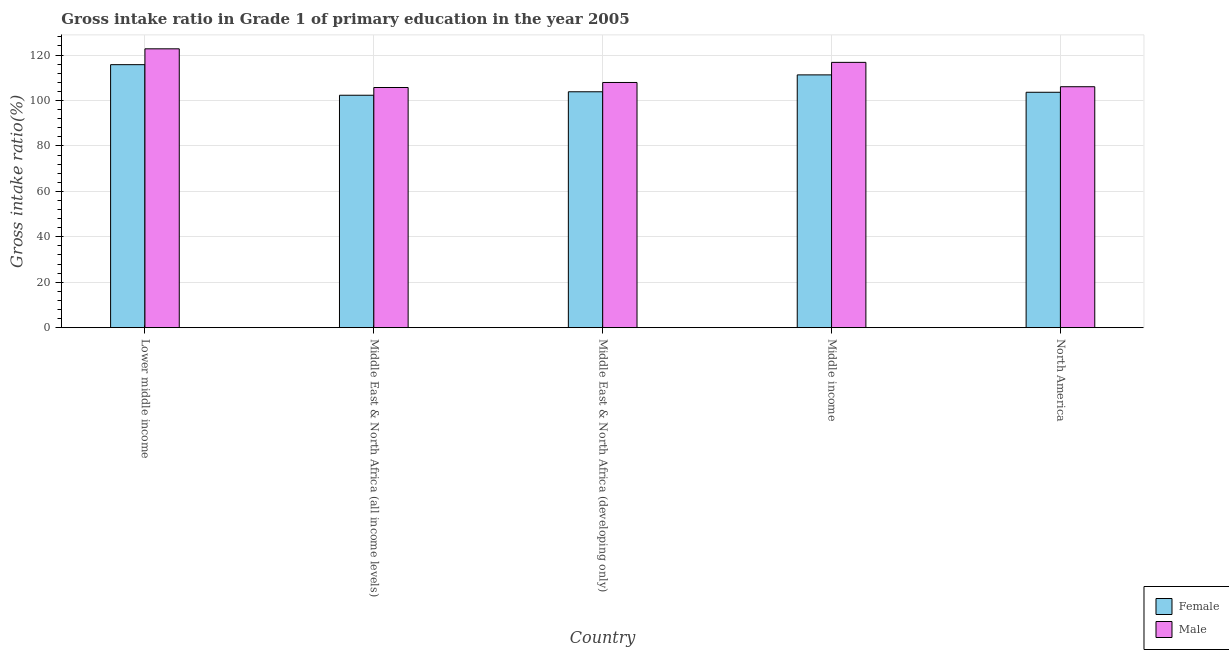How many different coloured bars are there?
Your response must be concise. 2. Are the number of bars per tick equal to the number of legend labels?
Provide a succinct answer. Yes. How many bars are there on the 1st tick from the left?
Provide a succinct answer. 2. What is the label of the 1st group of bars from the left?
Your answer should be compact. Lower middle income. In how many cases, is the number of bars for a given country not equal to the number of legend labels?
Offer a very short reply. 0. What is the gross intake ratio(female) in Middle East & North Africa (all income levels)?
Your answer should be very brief. 102.32. Across all countries, what is the maximum gross intake ratio(male)?
Offer a terse response. 122.75. Across all countries, what is the minimum gross intake ratio(male)?
Provide a succinct answer. 105.72. In which country was the gross intake ratio(female) maximum?
Your answer should be very brief. Lower middle income. In which country was the gross intake ratio(male) minimum?
Keep it short and to the point. Middle East & North Africa (all income levels). What is the total gross intake ratio(female) in the graph?
Offer a terse response. 536.83. What is the difference between the gross intake ratio(female) in Middle East & North Africa (all income levels) and that in Middle East & North Africa (developing only)?
Make the answer very short. -1.52. What is the difference between the gross intake ratio(female) in Lower middle income and the gross intake ratio(male) in Middle East & North Africa (all income levels)?
Ensure brevity in your answer.  10.06. What is the average gross intake ratio(male) per country?
Your answer should be very brief. 111.85. What is the difference between the gross intake ratio(female) and gross intake ratio(male) in Middle East & North Africa (all income levels)?
Your answer should be very brief. -3.4. What is the ratio of the gross intake ratio(female) in Middle East & North Africa (all income levels) to that in Middle income?
Offer a terse response. 0.92. Is the gross intake ratio(female) in Lower middle income less than that in Middle income?
Your response must be concise. No. What is the difference between the highest and the second highest gross intake ratio(female)?
Provide a short and direct response. 4.5. What is the difference between the highest and the lowest gross intake ratio(male)?
Ensure brevity in your answer.  17.03. Is the sum of the gross intake ratio(male) in Lower middle income and North America greater than the maximum gross intake ratio(female) across all countries?
Offer a very short reply. Yes. What does the 2nd bar from the left in North America represents?
Provide a short and direct response. Male. What does the 1st bar from the right in Middle income represents?
Your response must be concise. Male. Are the values on the major ticks of Y-axis written in scientific E-notation?
Your response must be concise. No. Does the graph contain any zero values?
Offer a very short reply. No. How are the legend labels stacked?
Keep it short and to the point. Vertical. What is the title of the graph?
Your response must be concise. Gross intake ratio in Grade 1 of primary education in the year 2005. What is the label or title of the Y-axis?
Give a very brief answer. Gross intake ratio(%). What is the Gross intake ratio(%) in Female in Lower middle income?
Give a very brief answer. 115.78. What is the Gross intake ratio(%) in Male in Lower middle income?
Your answer should be very brief. 122.75. What is the Gross intake ratio(%) of Female in Middle East & North Africa (all income levels)?
Offer a very short reply. 102.32. What is the Gross intake ratio(%) of Male in Middle East & North Africa (all income levels)?
Your response must be concise. 105.72. What is the Gross intake ratio(%) of Female in Middle East & North Africa (developing only)?
Your answer should be compact. 103.84. What is the Gross intake ratio(%) in Male in Middle East & North Africa (developing only)?
Keep it short and to the point. 107.93. What is the Gross intake ratio(%) in Female in Middle income?
Offer a terse response. 111.27. What is the Gross intake ratio(%) of Male in Middle income?
Provide a short and direct response. 116.79. What is the Gross intake ratio(%) of Female in North America?
Offer a terse response. 103.62. What is the Gross intake ratio(%) in Male in North America?
Offer a very short reply. 106.07. Across all countries, what is the maximum Gross intake ratio(%) in Female?
Offer a very short reply. 115.78. Across all countries, what is the maximum Gross intake ratio(%) of Male?
Give a very brief answer. 122.75. Across all countries, what is the minimum Gross intake ratio(%) in Female?
Provide a succinct answer. 102.32. Across all countries, what is the minimum Gross intake ratio(%) in Male?
Ensure brevity in your answer.  105.72. What is the total Gross intake ratio(%) of Female in the graph?
Your answer should be compact. 536.83. What is the total Gross intake ratio(%) of Male in the graph?
Offer a very short reply. 559.25. What is the difference between the Gross intake ratio(%) in Female in Lower middle income and that in Middle East & North Africa (all income levels)?
Provide a short and direct response. 13.46. What is the difference between the Gross intake ratio(%) in Male in Lower middle income and that in Middle East & North Africa (all income levels)?
Provide a short and direct response. 17.03. What is the difference between the Gross intake ratio(%) in Female in Lower middle income and that in Middle East & North Africa (developing only)?
Provide a short and direct response. 11.94. What is the difference between the Gross intake ratio(%) in Male in Lower middle income and that in Middle East & North Africa (developing only)?
Give a very brief answer. 14.82. What is the difference between the Gross intake ratio(%) in Female in Lower middle income and that in Middle income?
Your answer should be compact. 4.5. What is the difference between the Gross intake ratio(%) in Male in Lower middle income and that in Middle income?
Make the answer very short. 5.96. What is the difference between the Gross intake ratio(%) in Female in Lower middle income and that in North America?
Your answer should be compact. 12.15. What is the difference between the Gross intake ratio(%) in Male in Lower middle income and that in North America?
Give a very brief answer. 16.68. What is the difference between the Gross intake ratio(%) of Female in Middle East & North Africa (all income levels) and that in Middle East & North Africa (developing only)?
Offer a terse response. -1.52. What is the difference between the Gross intake ratio(%) of Male in Middle East & North Africa (all income levels) and that in Middle East & North Africa (developing only)?
Your response must be concise. -2.21. What is the difference between the Gross intake ratio(%) in Female in Middle East & North Africa (all income levels) and that in Middle income?
Ensure brevity in your answer.  -8.96. What is the difference between the Gross intake ratio(%) of Male in Middle East & North Africa (all income levels) and that in Middle income?
Keep it short and to the point. -11.07. What is the difference between the Gross intake ratio(%) in Female in Middle East & North Africa (all income levels) and that in North America?
Give a very brief answer. -1.31. What is the difference between the Gross intake ratio(%) of Male in Middle East & North Africa (all income levels) and that in North America?
Provide a succinct answer. -0.35. What is the difference between the Gross intake ratio(%) in Female in Middle East & North Africa (developing only) and that in Middle income?
Offer a very short reply. -7.44. What is the difference between the Gross intake ratio(%) of Male in Middle East & North Africa (developing only) and that in Middle income?
Your answer should be very brief. -8.86. What is the difference between the Gross intake ratio(%) in Female in Middle East & North Africa (developing only) and that in North America?
Provide a short and direct response. 0.22. What is the difference between the Gross intake ratio(%) of Male in Middle East & North Africa (developing only) and that in North America?
Offer a terse response. 1.86. What is the difference between the Gross intake ratio(%) of Female in Middle income and that in North America?
Your answer should be compact. 7.65. What is the difference between the Gross intake ratio(%) in Male in Middle income and that in North America?
Offer a very short reply. 10.72. What is the difference between the Gross intake ratio(%) in Female in Lower middle income and the Gross intake ratio(%) in Male in Middle East & North Africa (all income levels)?
Your answer should be very brief. 10.06. What is the difference between the Gross intake ratio(%) of Female in Lower middle income and the Gross intake ratio(%) of Male in Middle East & North Africa (developing only)?
Your answer should be very brief. 7.85. What is the difference between the Gross intake ratio(%) of Female in Lower middle income and the Gross intake ratio(%) of Male in Middle income?
Ensure brevity in your answer.  -1.01. What is the difference between the Gross intake ratio(%) in Female in Lower middle income and the Gross intake ratio(%) in Male in North America?
Your answer should be compact. 9.71. What is the difference between the Gross intake ratio(%) of Female in Middle East & North Africa (all income levels) and the Gross intake ratio(%) of Male in Middle East & North Africa (developing only)?
Offer a very short reply. -5.61. What is the difference between the Gross intake ratio(%) in Female in Middle East & North Africa (all income levels) and the Gross intake ratio(%) in Male in Middle income?
Your response must be concise. -14.47. What is the difference between the Gross intake ratio(%) of Female in Middle East & North Africa (all income levels) and the Gross intake ratio(%) of Male in North America?
Provide a succinct answer. -3.75. What is the difference between the Gross intake ratio(%) of Female in Middle East & North Africa (developing only) and the Gross intake ratio(%) of Male in Middle income?
Offer a very short reply. -12.95. What is the difference between the Gross intake ratio(%) of Female in Middle East & North Africa (developing only) and the Gross intake ratio(%) of Male in North America?
Keep it short and to the point. -2.23. What is the difference between the Gross intake ratio(%) of Female in Middle income and the Gross intake ratio(%) of Male in North America?
Make the answer very short. 5.21. What is the average Gross intake ratio(%) in Female per country?
Your answer should be very brief. 107.37. What is the average Gross intake ratio(%) of Male per country?
Keep it short and to the point. 111.85. What is the difference between the Gross intake ratio(%) in Female and Gross intake ratio(%) in Male in Lower middle income?
Provide a succinct answer. -6.97. What is the difference between the Gross intake ratio(%) of Female and Gross intake ratio(%) of Male in Middle East & North Africa (all income levels)?
Your answer should be very brief. -3.4. What is the difference between the Gross intake ratio(%) of Female and Gross intake ratio(%) of Male in Middle East & North Africa (developing only)?
Ensure brevity in your answer.  -4.09. What is the difference between the Gross intake ratio(%) in Female and Gross intake ratio(%) in Male in Middle income?
Provide a short and direct response. -5.51. What is the difference between the Gross intake ratio(%) in Female and Gross intake ratio(%) in Male in North America?
Your response must be concise. -2.44. What is the ratio of the Gross intake ratio(%) in Female in Lower middle income to that in Middle East & North Africa (all income levels)?
Give a very brief answer. 1.13. What is the ratio of the Gross intake ratio(%) in Male in Lower middle income to that in Middle East & North Africa (all income levels)?
Ensure brevity in your answer.  1.16. What is the ratio of the Gross intake ratio(%) of Female in Lower middle income to that in Middle East & North Africa (developing only)?
Your answer should be very brief. 1.11. What is the ratio of the Gross intake ratio(%) in Male in Lower middle income to that in Middle East & North Africa (developing only)?
Provide a succinct answer. 1.14. What is the ratio of the Gross intake ratio(%) of Female in Lower middle income to that in Middle income?
Offer a very short reply. 1.04. What is the ratio of the Gross intake ratio(%) in Male in Lower middle income to that in Middle income?
Make the answer very short. 1.05. What is the ratio of the Gross intake ratio(%) in Female in Lower middle income to that in North America?
Your response must be concise. 1.12. What is the ratio of the Gross intake ratio(%) of Male in Lower middle income to that in North America?
Provide a short and direct response. 1.16. What is the ratio of the Gross intake ratio(%) of Female in Middle East & North Africa (all income levels) to that in Middle East & North Africa (developing only)?
Offer a terse response. 0.99. What is the ratio of the Gross intake ratio(%) in Male in Middle East & North Africa (all income levels) to that in Middle East & North Africa (developing only)?
Make the answer very short. 0.98. What is the ratio of the Gross intake ratio(%) of Female in Middle East & North Africa (all income levels) to that in Middle income?
Keep it short and to the point. 0.92. What is the ratio of the Gross intake ratio(%) of Male in Middle East & North Africa (all income levels) to that in Middle income?
Provide a succinct answer. 0.91. What is the ratio of the Gross intake ratio(%) of Female in Middle East & North Africa (all income levels) to that in North America?
Your answer should be compact. 0.99. What is the ratio of the Gross intake ratio(%) in Female in Middle East & North Africa (developing only) to that in Middle income?
Offer a terse response. 0.93. What is the ratio of the Gross intake ratio(%) in Male in Middle East & North Africa (developing only) to that in Middle income?
Offer a terse response. 0.92. What is the ratio of the Gross intake ratio(%) in Male in Middle East & North Africa (developing only) to that in North America?
Offer a very short reply. 1.02. What is the ratio of the Gross intake ratio(%) of Female in Middle income to that in North America?
Keep it short and to the point. 1.07. What is the ratio of the Gross intake ratio(%) in Male in Middle income to that in North America?
Make the answer very short. 1.1. What is the difference between the highest and the second highest Gross intake ratio(%) in Female?
Your answer should be very brief. 4.5. What is the difference between the highest and the second highest Gross intake ratio(%) of Male?
Your answer should be compact. 5.96. What is the difference between the highest and the lowest Gross intake ratio(%) in Female?
Your response must be concise. 13.46. What is the difference between the highest and the lowest Gross intake ratio(%) in Male?
Your response must be concise. 17.03. 